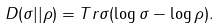<formula> <loc_0><loc_0><loc_500><loc_500>D ( \sigma | | \rho ) = T r \sigma ( \log \sigma - \log \rho ) .</formula> 